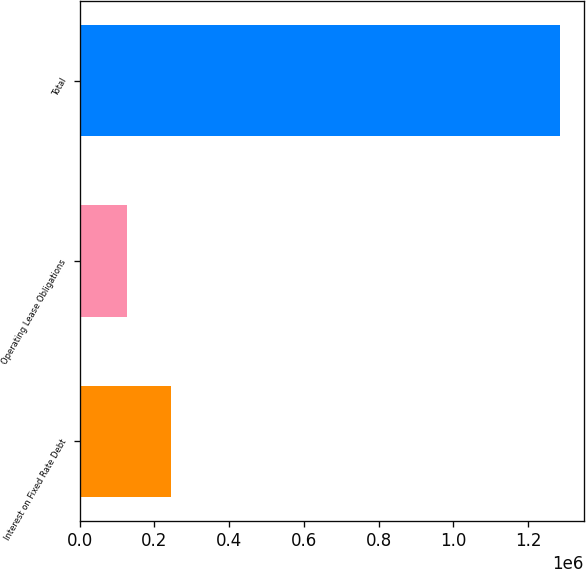Convert chart to OTSL. <chart><loc_0><loc_0><loc_500><loc_500><bar_chart><fcel>Interest on Fixed Rate Debt<fcel>Operating Lease Obligations<fcel>Total<nl><fcel>243134<fcel>127387<fcel>1.28485e+06<nl></chart> 